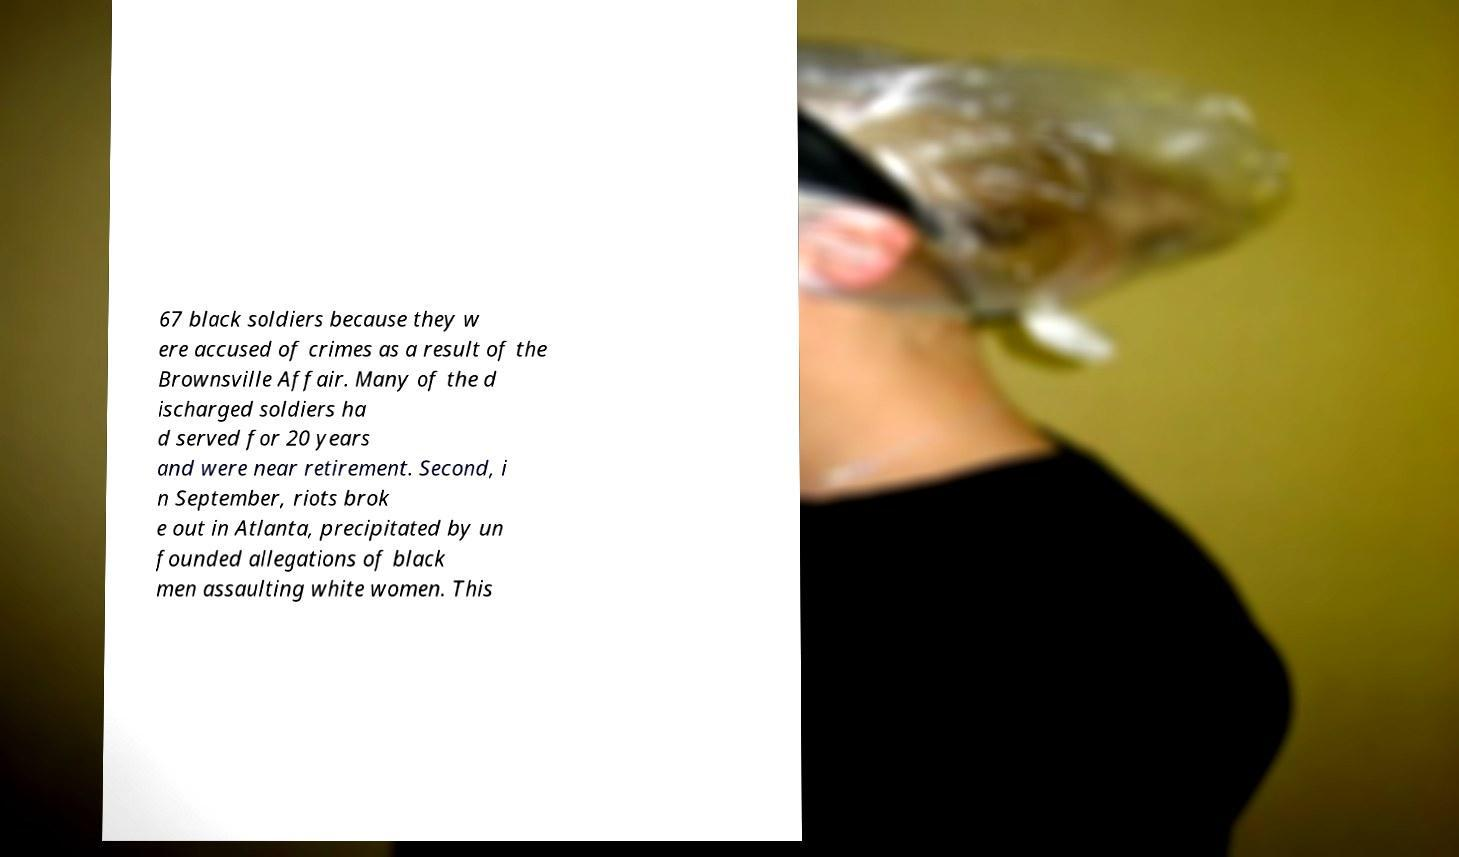Could you assist in decoding the text presented in this image and type it out clearly? 67 black soldiers because they w ere accused of crimes as a result of the Brownsville Affair. Many of the d ischarged soldiers ha d served for 20 years and were near retirement. Second, i n September, riots brok e out in Atlanta, precipitated by un founded allegations of black men assaulting white women. This 